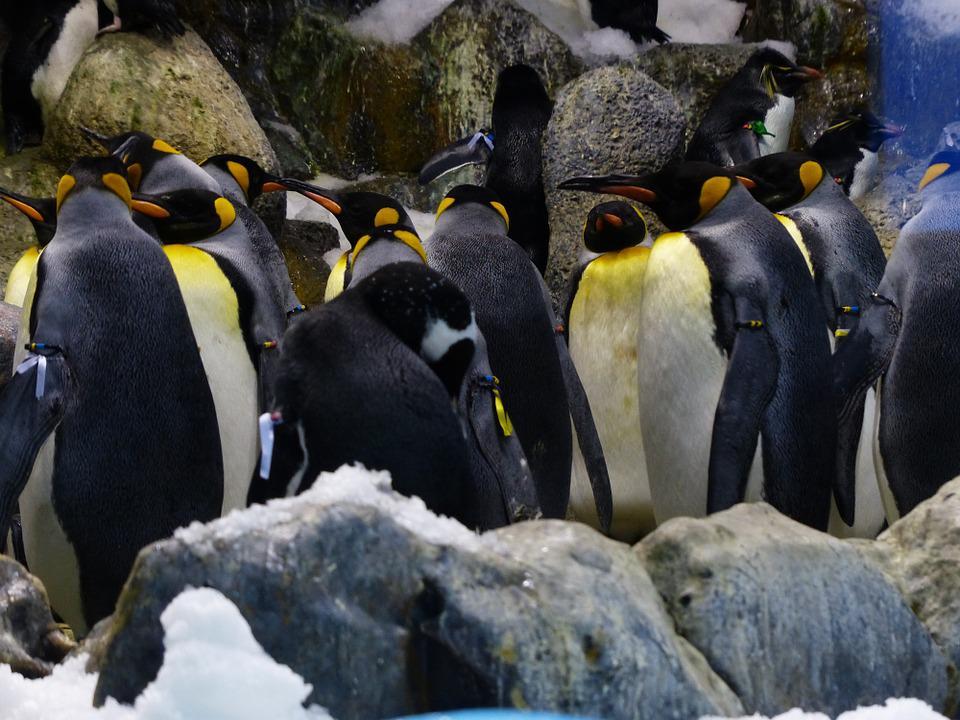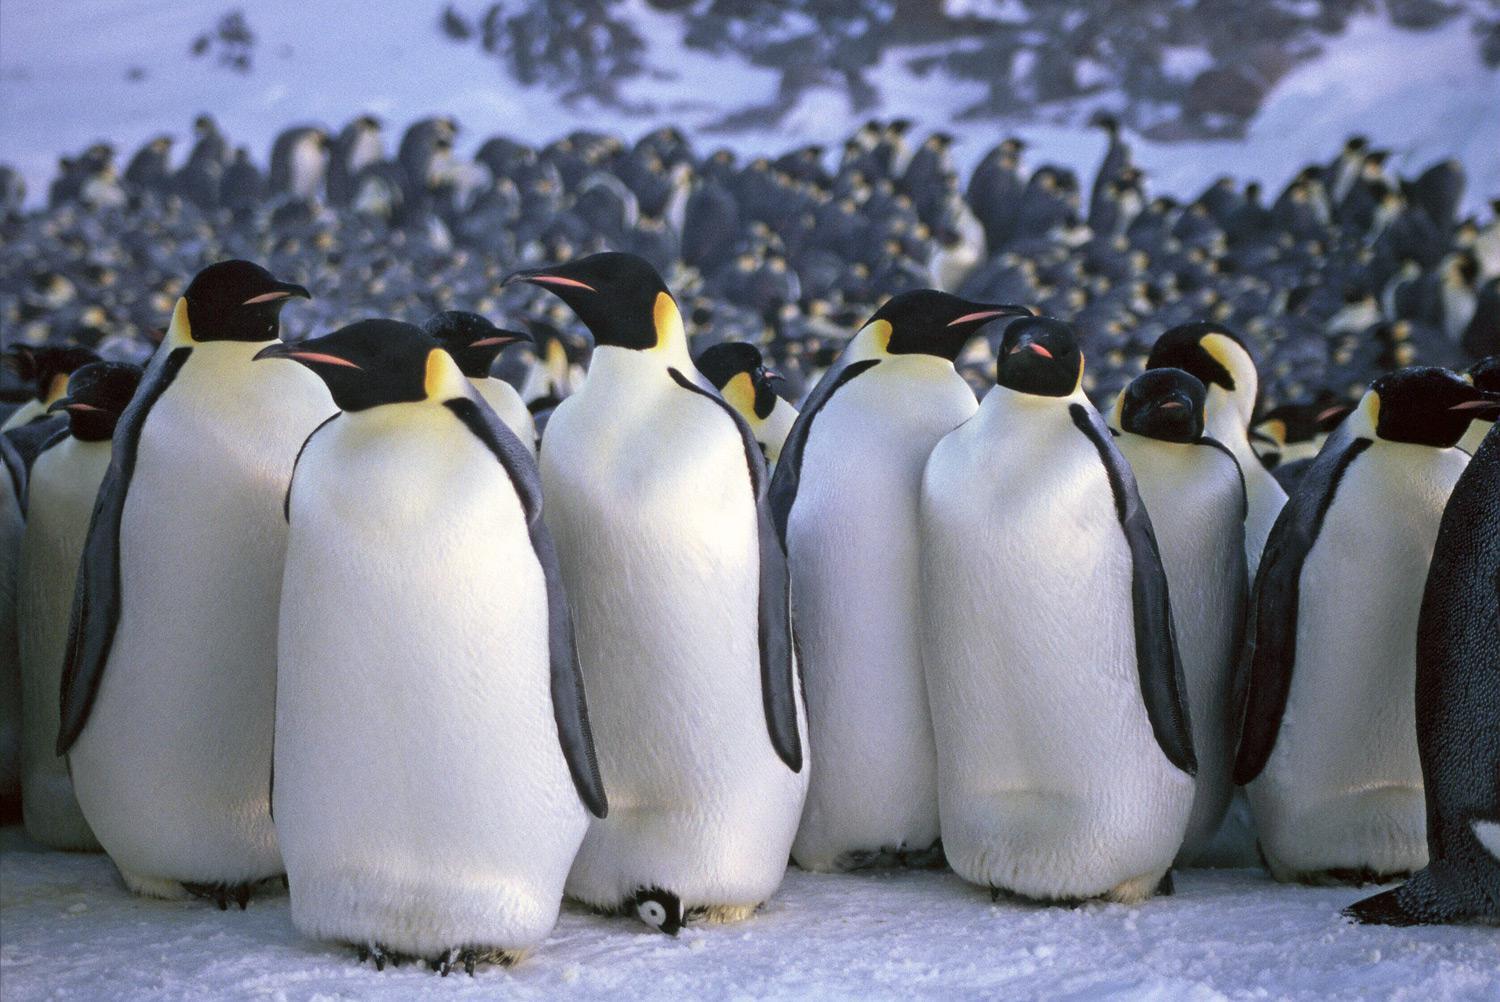The first image is the image on the left, the second image is the image on the right. Assess this claim about the two images: "There are no more than four penguins standing together in the image on the left.". Correct or not? Answer yes or no. No. The first image is the image on the left, the second image is the image on the right. Analyze the images presented: Is the assertion "Left image contains multiple penguins with backs turned to the camera." valid? Answer yes or no. Yes. 